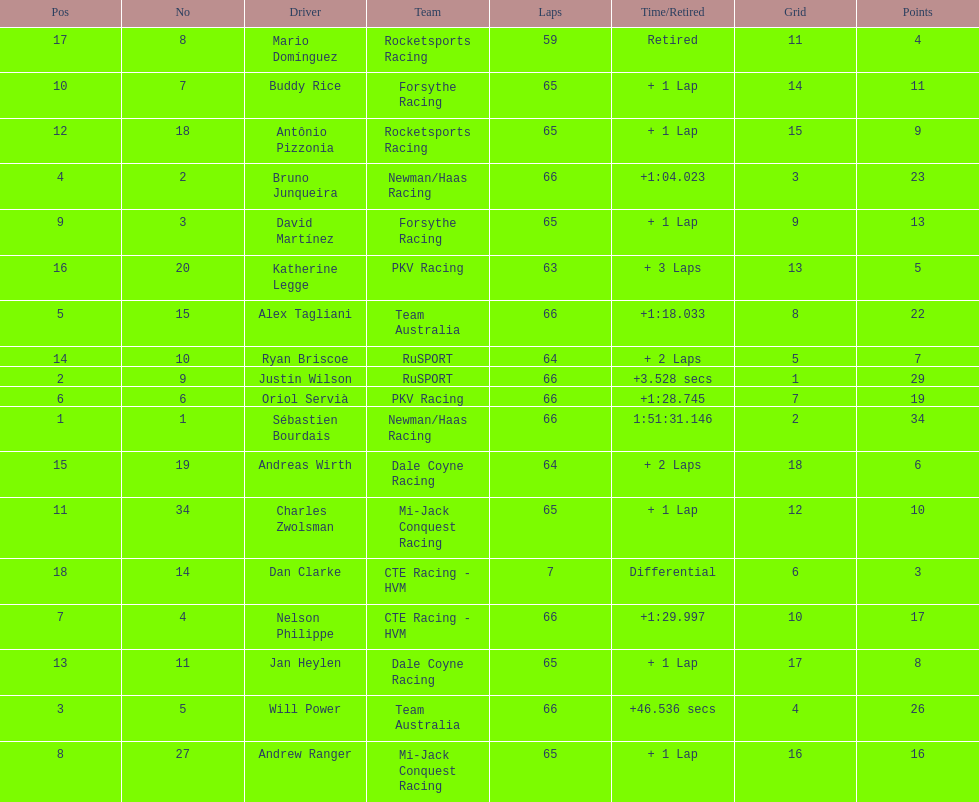Which country had more drivers representing them, the us or germany? Tie. 